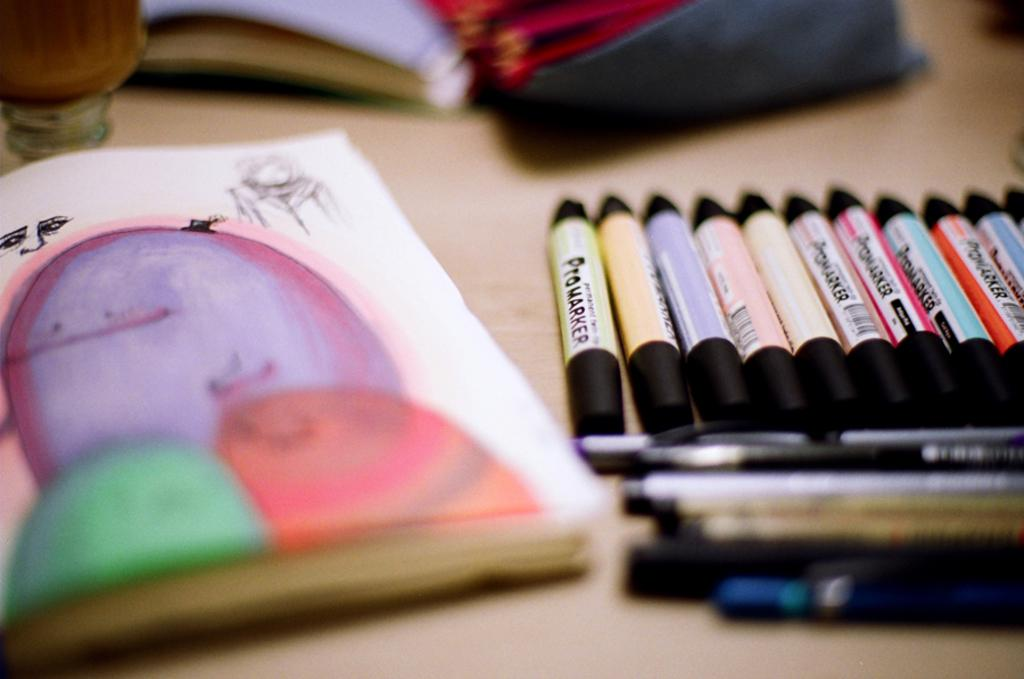What types of writing instruments are visible in the image? There are crayons and pens in the image. What else can be seen in the image besides writing instruments? There are books in the image. How are these items arranged in the image? All of these items are placed on a platform. Can you describe the unspecified objects in the image? Unfortunately, the facts provided do not specify the nature of the unspecified objects. What verse is being recited by the aunt in the image? There is no mention of an aunt or any verse being recited in the image. 